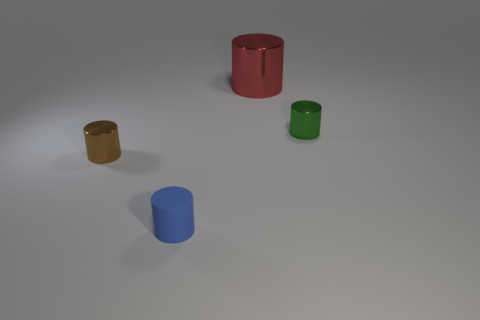Subtract all large metallic cylinders. How many cylinders are left? 3 Subtract all green cylinders. How many cylinders are left? 3 Add 3 big shiny cubes. How many objects exist? 7 Subtract 2 cylinders. How many cylinders are left? 2 Subtract all brown metallic blocks. Subtract all brown cylinders. How many objects are left? 3 Add 4 tiny green shiny cylinders. How many tiny green shiny cylinders are left? 5 Add 4 small gray blocks. How many small gray blocks exist? 4 Subtract 1 red cylinders. How many objects are left? 3 Subtract all purple cylinders. Subtract all red blocks. How many cylinders are left? 4 